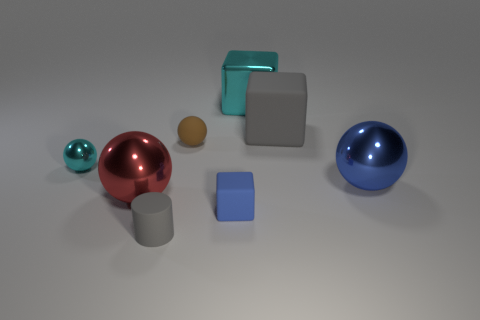Is the material of the sphere that is to the right of the matte sphere the same as the large red thing?
Keep it short and to the point. Yes. What material is the small thing that is both to the left of the brown matte object and behind the gray cylinder?
Your answer should be compact. Metal. What color is the rubber cube that is behind the cyan shiny object that is in front of the big cyan metal object?
Your answer should be compact. Gray. There is a big gray object that is the same shape as the blue matte object; what is it made of?
Offer a very short reply. Rubber. There is a big metallic ball on the left side of the large shiny thing that is behind the metallic ball right of the tiny cylinder; what color is it?
Provide a short and direct response. Red. How many objects are either tiny metallic things or gray cubes?
Offer a very short reply. 2. How many cyan objects are the same shape as the small gray object?
Your answer should be very brief. 0. Is the material of the gray cube the same as the object in front of the small blue rubber thing?
Offer a very short reply. Yes. There is a gray block that is the same material as the tiny blue block; what is its size?
Give a very brief answer. Large. What is the size of the gray rubber object that is right of the small blue rubber cube?
Ensure brevity in your answer.  Large. 